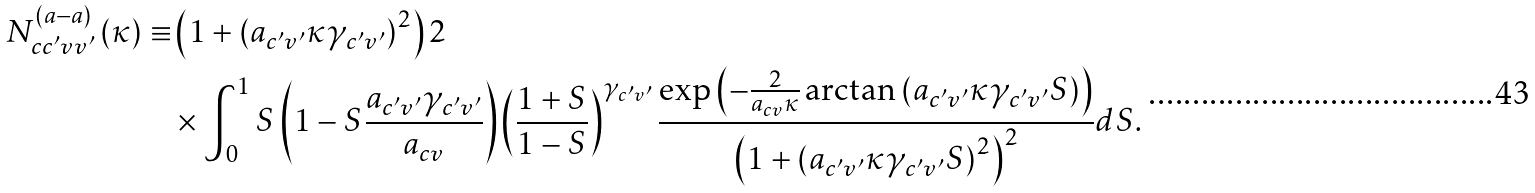Convert formula to latex. <formula><loc_0><loc_0><loc_500><loc_500>N ^ { ( a - a ) } _ { c c ^ { \prime } v v ^ { \prime } } \left ( \kappa \right ) \equiv & \left ( 1 + \left ( a _ { c ^ { \prime } v ^ { \prime } } \kappa \gamma _ { c ^ { \prime } v ^ { \prime } } \right ) ^ { 2 } \right ) 2 \\ & \times \int _ { 0 } ^ { 1 } S \left ( 1 - S \frac { a _ { c ^ { \prime } v ^ { \prime } } \gamma _ { c ^ { \prime } v ^ { \prime } } } { a _ { c v } } \right ) \left ( \frac { 1 + S } { 1 - S } \right ) ^ { \gamma _ { c ^ { \prime } v ^ { \prime } } } \frac { \exp \left ( - \frac { 2 } { a _ { c v } \kappa } \arctan \left ( a _ { c ^ { \prime } v ^ { \prime } } \kappa \gamma _ { c ^ { \prime } v ^ { \prime } } S \right ) \right ) } { \left ( 1 + \left ( a _ { c ^ { \prime } v ^ { \prime } } \kappa \gamma _ { c ^ { \prime } v ^ { \prime } } S \right ) ^ { 2 } \right ) ^ { 2 } } d S .</formula> 